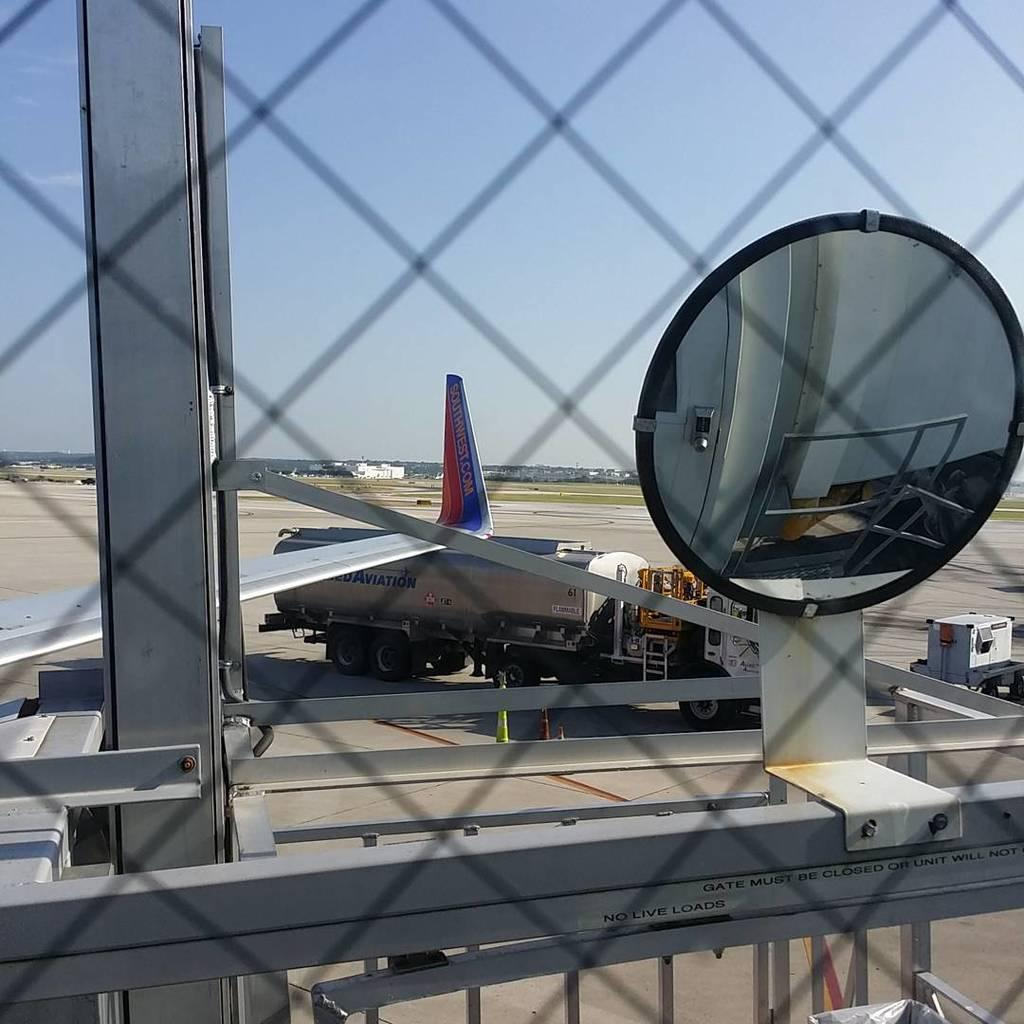Provide a one-sentence caption for the provided image. A Southwest airplane at an airport next to a fuel truck. 